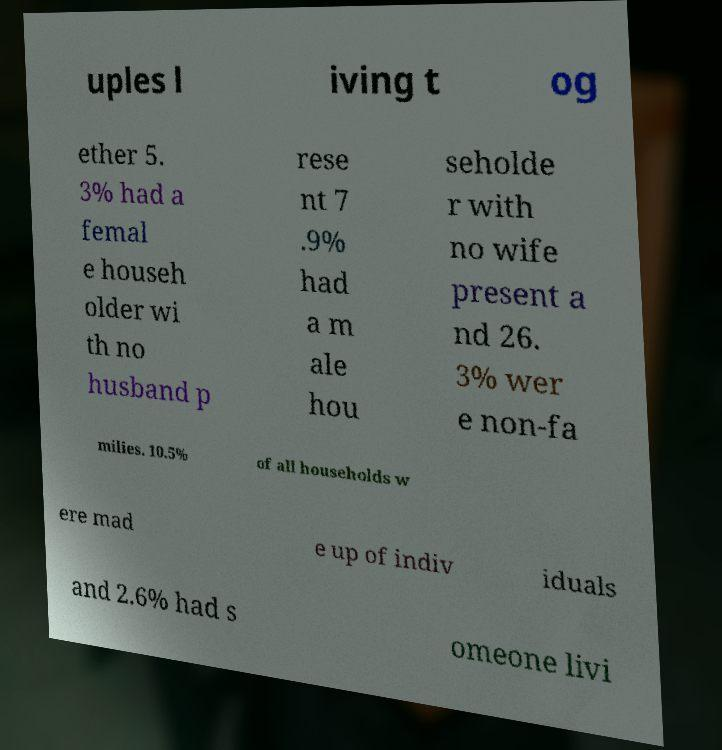For documentation purposes, I need the text within this image transcribed. Could you provide that? uples l iving t og ether 5. 3% had a femal e househ older wi th no husband p rese nt 7 .9% had a m ale hou seholde r with no wife present a nd 26. 3% wer e non-fa milies. 10.5% of all households w ere mad e up of indiv iduals and 2.6% had s omeone livi 